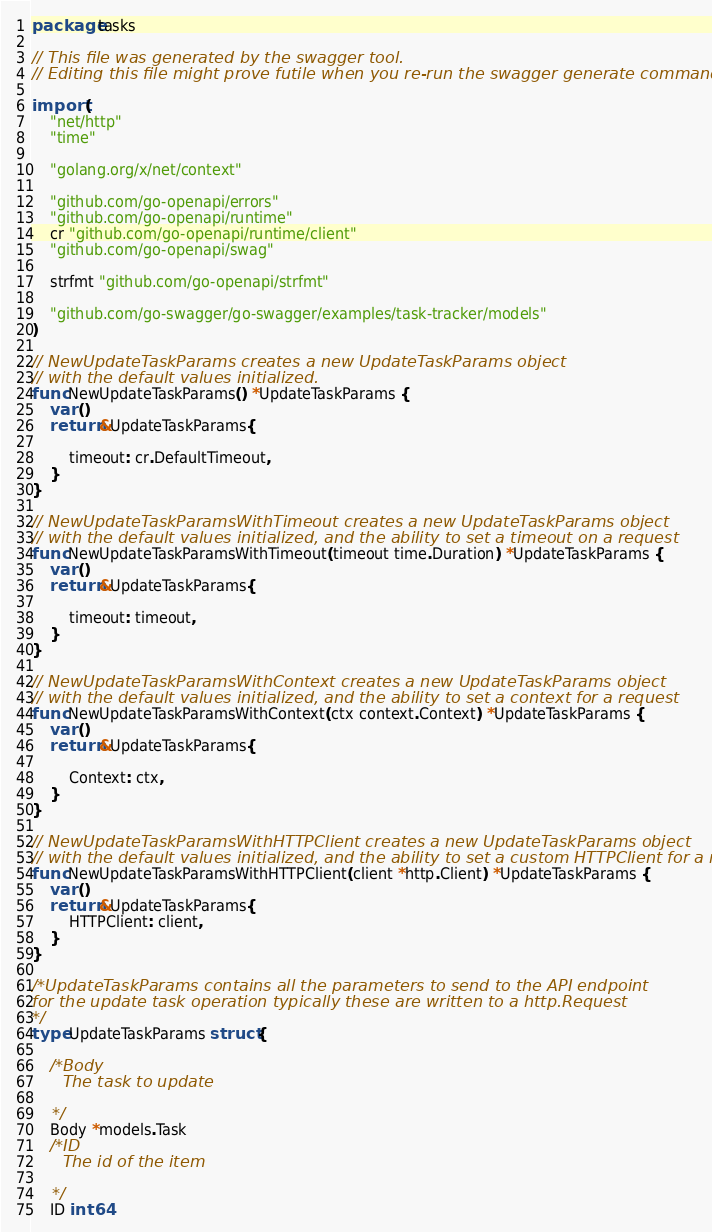Convert code to text. <code><loc_0><loc_0><loc_500><loc_500><_Go_>package tasks

// This file was generated by the swagger tool.
// Editing this file might prove futile when you re-run the swagger generate command

import (
	"net/http"
	"time"

	"golang.org/x/net/context"

	"github.com/go-openapi/errors"
	"github.com/go-openapi/runtime"
	cr "github.com/go-openapi/runtime/client"
	"github.com/go-openapi/swag"

	strfmt "github.com/go-openapi/strfmt"

	"github.com/go-swagger/go-swagger/examples/task-tracker/models"
)

// NewUpdateTaskParams creates a new UpdateTaskParams object
// with the default values initialized.
func NewUpdateTaskParams() *UpdateTaskParams {
	var ()
	return &UpdateTaskParams{

		timeout: cr.DefaultTimeout,
	}
}

// NewUpdateTaskParamsWithTimeout creates a new UpdateTaskParams object
// with the default values initialized, and the ability to set a timeout on a request
func NewUpdateTaskParamsWithTimeout(timeout time.Duration) *UpdateTaskParams {
	var ()
	return &UpdateTaskParams{

		timeout: timeout,
	}
}

// NewUpdateTaskParamsWithContext creates a new UpdateTaskParams object
// with the default values initialized, and the ability to set a context for a request
func NewUpdateTaskParamsWithContext(ctx context.Context) *UpdateTaskParams {
	var ()
	return &UpdateTaskParams{

		Context: ctx,
	}
}

// NewUpdateTaskParamsWithHTTPClient creates a new UpdateTaskParams object
// with the default values initialized, and the ability to set a custom HTTPClient for a request
func NewUpdateTaskParamsWithHTTPClient(client *http.Client) *UpdateTaskParams {
	var ()
	return &UpdateTaskParams{
		HTTPClient: client,
	}
}

/*UpdateTaskParams contains all the parameters to send to the API endpoint
for the update task operation typically these are written to a http.Request
*/
type UpdateTaskParams struct {

	/*Body
	  The task to update

	*/
	Body *models.Task
	/*ID
	  The id of the item

	*/
	ID int64
</code> 